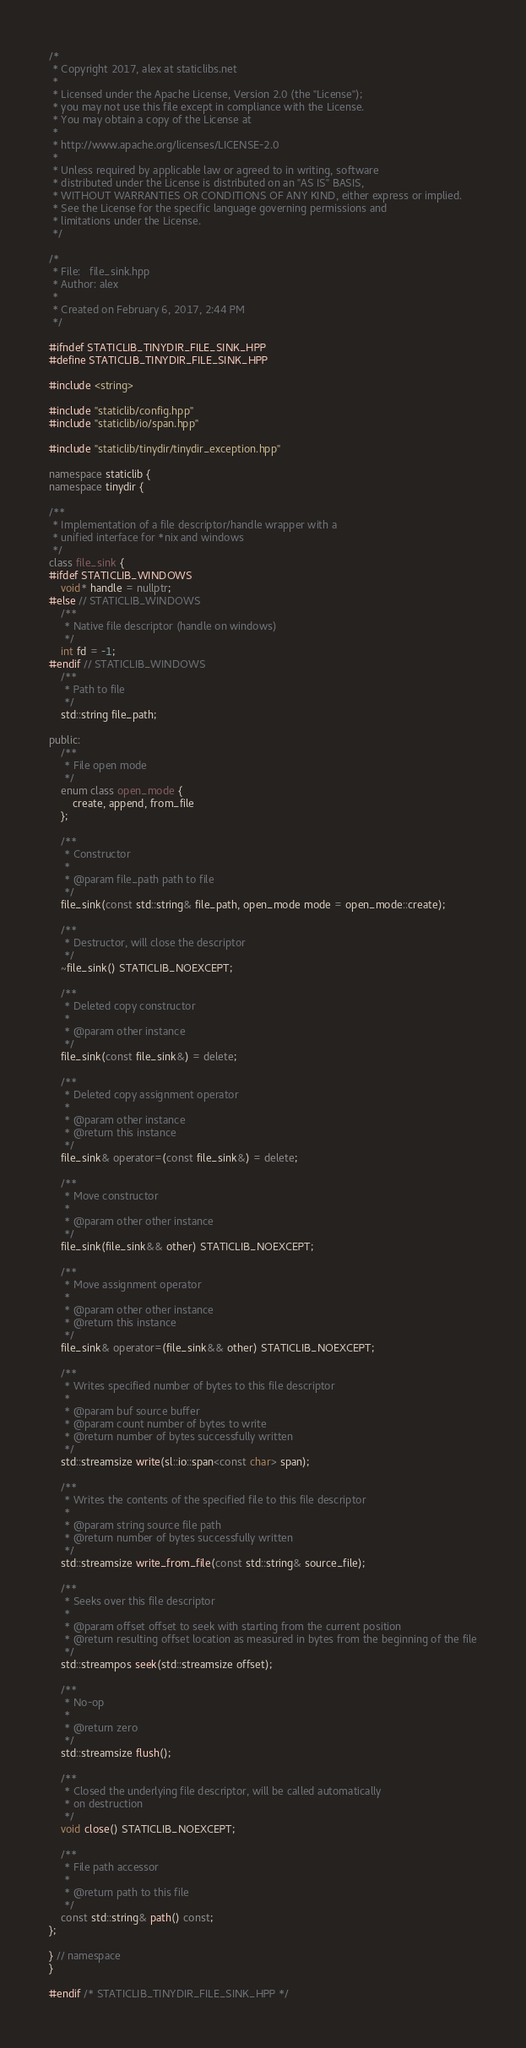<code> <loc_0><loc_0><loc_500><loc_500><_C++_>/*
 * Copyright 2017, alex at staticlibs.net
 *
 * Licensed under the Apache License, Version 2.0 (the "License");
 * you may not use this file except in compliance with the License.
 * You may obtain a copy of the License at
 *
 * http://www.apache.org/licenses/LICENSE-2.0
 *
 * Unless required by applicable law or agreed to in writing, software
 * distributed under the License is distributed on an "AS IS" BASIS,
 * WITHOUT WARRANTIES OR CONDITIONS OF ANY KIND, either express or implied.
 * See the License for the specific language governing permissions and
 * limitations under the License.
 */

/* 
 * File:   file_sink.hpp
 * Author: alex
 *
 * Created on February 6, 2017, 2:44 PM
 */

#ifndef STATICLIB_TINYDIR_FILE_SINK_HPP
#define STATICLIB_TINYDIR_FILE_SINK_HPP

#include <string>

#include "staticlib/config.hpp"
#include "staticlib/io/span.hpp"

#include "staticlib/tinydir/tinydir_exception.hpp"

namespace staticlib {
namespace tinydir {

/**
 * Implementation of a file descriptor/handle wrapper with a 
 * unified interface for *nix and windows
 */
class file_sink {
#ifdef STATICLIB_WINDOWS
    void* handle = nullptr;
#else // STATICLIB_WINDOWS
    /**
     * Native file descriptor (handle on windows)
     */
    int fd = -1;
#endif // STATICLIB_WINDOWS
    /**
     * Path to file
     */
    std::string file_path;

public:
    /**
     * File open mode
     */
    enum class open_mode {
        create, append, from_file
    };

    /**
     * Constructor
     * 
     * @param file_path path to file
     */
    file_sink(const std::string& file_path, open_mode mode = open_mode::create);

    /**
     * Destructor, will close the descriptor
     */
    ~file_sink() STATICLIB_NOEXCEPT;

    /**
     * Deleted copy constructor
     * 
     * @param other instance
     */
    file_sink(const file_sink&) = delete;

    /**
     * Deleted copy assignment operator
     * 
     * @param other instance
     * @return this instance
     */
    file_sink& operator=(const file_sink&) = delete;

    /**
     * Move constructor
     * 
     * @param other other instance
     */
    file_sink(file_sink&& other) STATICLIB_NOEXCEPT;

    /**
     * Move assignment operator
     * 
     * @param other other instance
     * @return this instance
     */
    file_sink& operator=(file_sink&& other) STATICLIB_NOEXCEPT;

    /**
     * Writes specified number of bytes to this file descriptor
     * 
     * @param buf source buffer
     * @param count number of bytes to write
     * @return number of bytes successfully written
     */
    std::streamsize write(sl::io::span<const char> span);

    /**
     * Writes the contents of the specified file to this file descriptor
     *
     * @param string source file path
     * @return number of bytes successfully written
     */
    std::streamsize write_from_file(const std::string& source_file);

    /**
     * Seeks over this file descriptor
     *
     * @param offset offset to seek with starting from the current position
     * @return resulting offset location as measured in bytes from the beginning of the file
     */
    std::streampos seek(std::streamsize offset);

    /**
     * No-op
     * 
     * @return zero
     */
    std::streamsize flush();

    /**
     * Closed the underlying file descriptor, will be called automatically 
     * on destruction
     */
    void close() STATICLIB_NOEXCEPT;

    /**
     * File path accessor
     * 
     * @return path to this file
     */
    const std::string& path() const;
};

} // namespace
}

#endif /* STATICLIB_TINYDIR_FILE_SINK_HPP */

</code> 